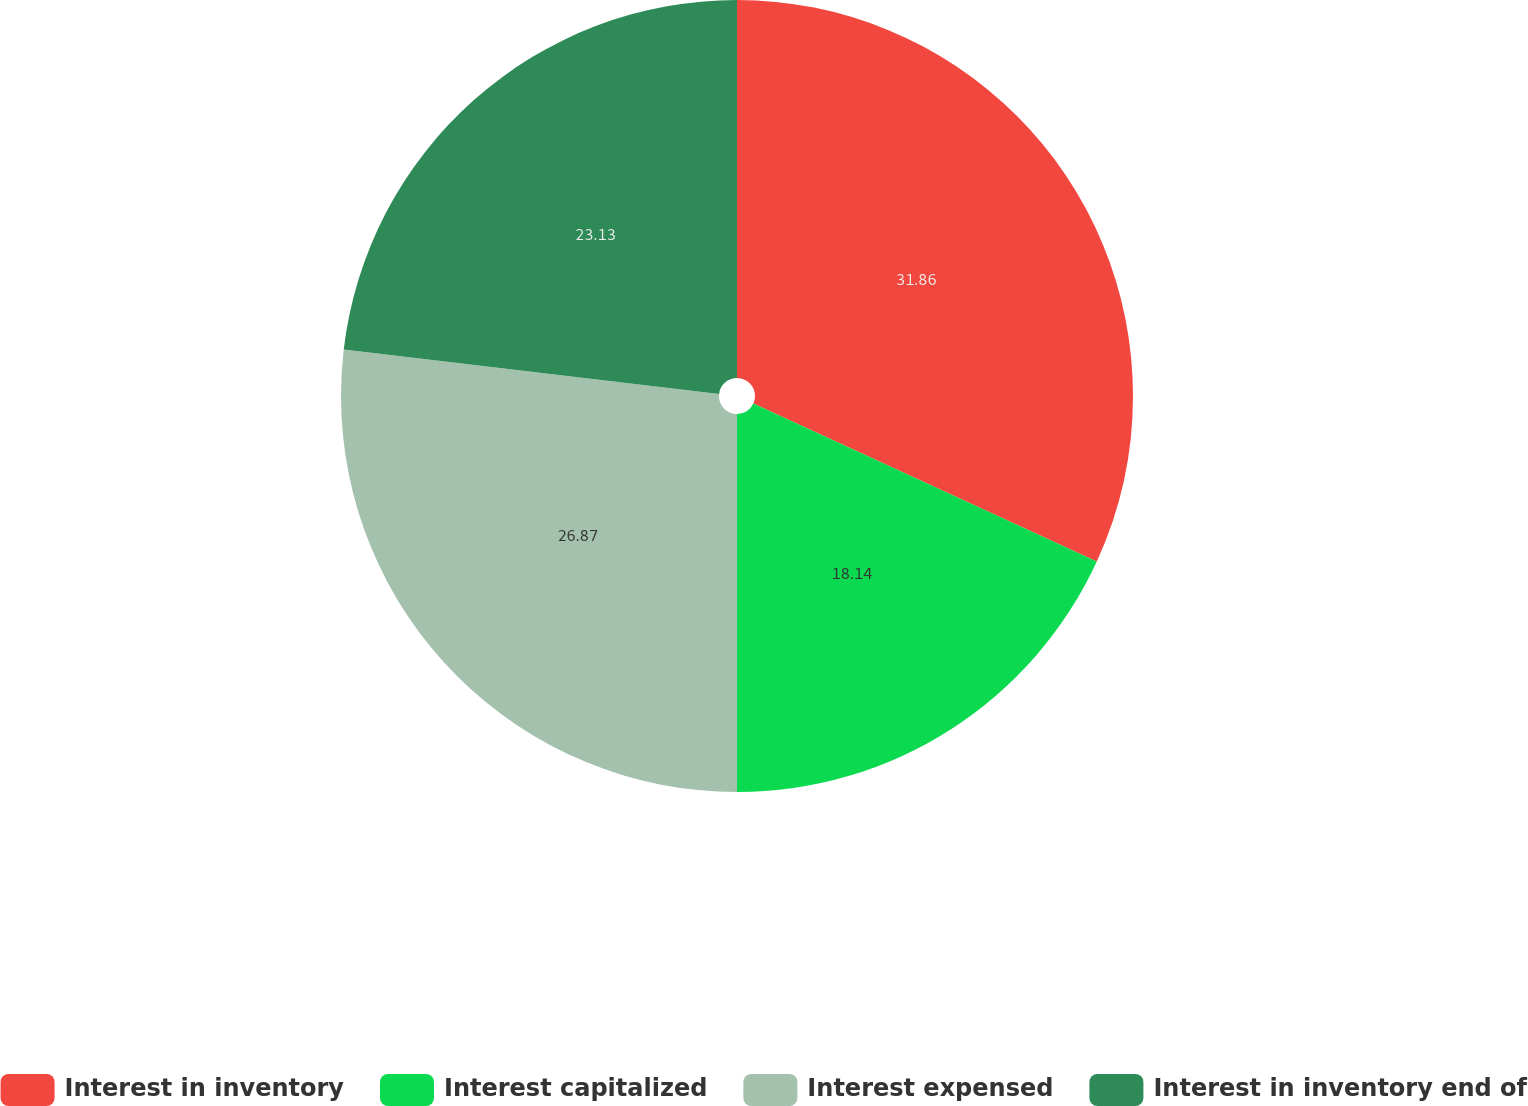Convert chart to OTSL. <chart><loc_0><loc_0><loc_500><loc_500><pie_chart><fcel>Interest in inventory<fcel>Interest capitalized<fcel>Interest expensed<fcel>Interest in inventory end of<nl><fcel>31.86%<fcel>18.14%<fcel>26.87%<fcel>23.13%<nl></chart> 